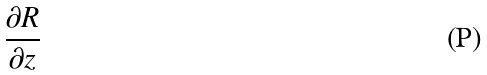Convert formula to latex. <formula><loc_0><loc_0><loc_500><loc_500>\frac { \partial R } { \partial z }</formula> 